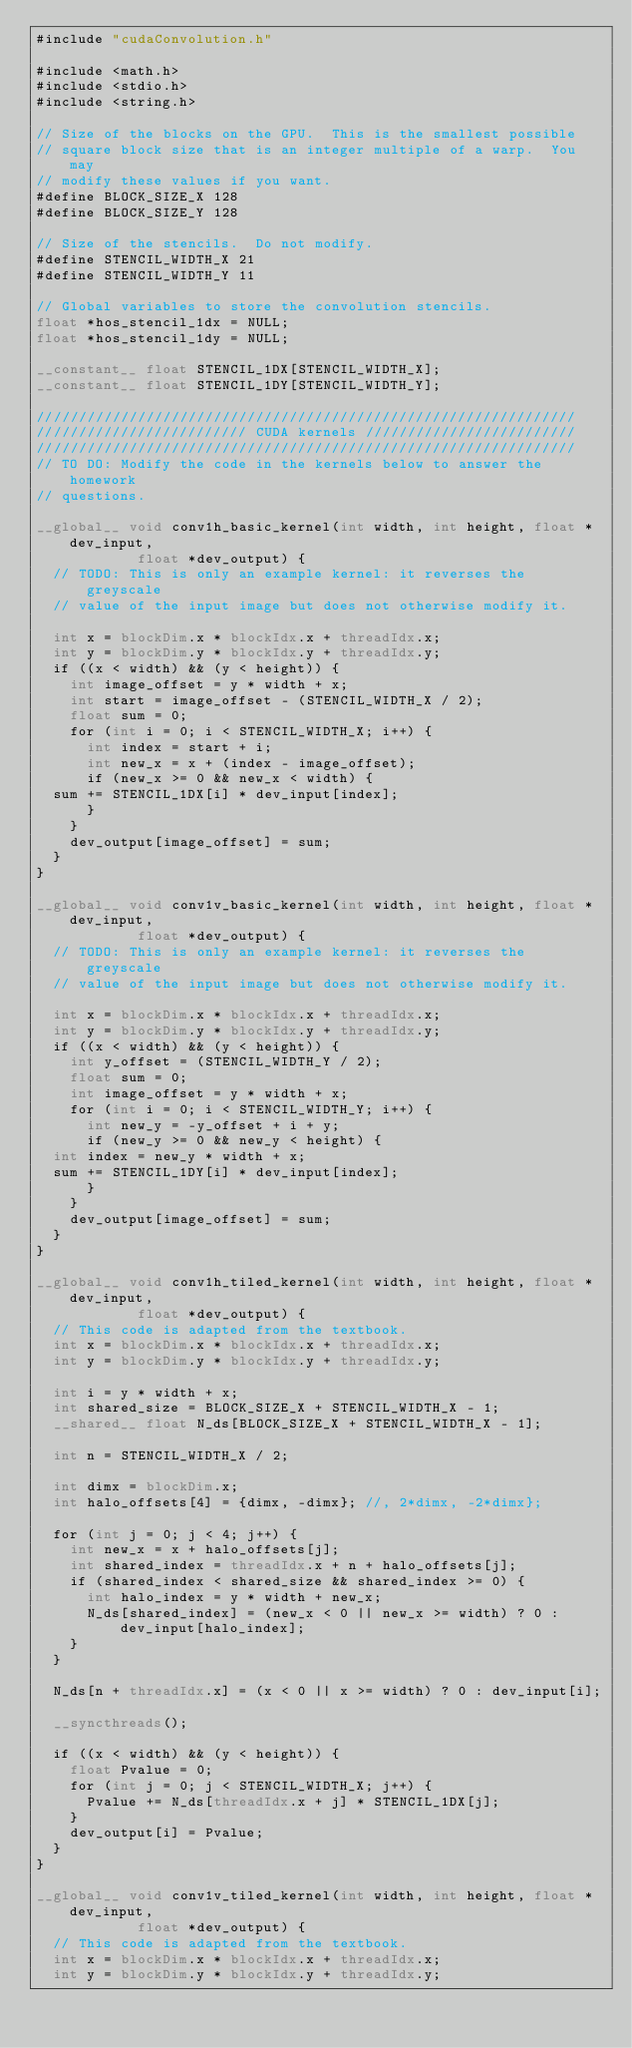<code> <loc_0><loc_0><loc_500><loc_500><_Cuda_>#include "cudaConvolution.h"

#include <math.h>
#include <stdio.h>
#include <string.h>

// Size of the blocks on the GPU.  This is the smallest possible
// square block size that is an integer multiple of a warp.  You may
// modify these values if you want.
#define BLOCK_SIZE_X 128
#define BLOCK_SIZE_Y 128

// Size of the stencils.  Do not modify.
#define STENCIL_WIDTH_X 21
#define STENCIL_WIDTH_Y 11

// Global variables to store the convolution stencils.
float *hos_stencil_1dx = NULL;
float *hos_stencil_1dy = NULL;

__constant__ float STENCIL_1DX[STENCIL_WIDTH_X];
__constant__ float STENCIL_1DY[STENCIL_WIDTH_Y];

////////////////////////////////////////////////////////////////
///////////////////////// CUDA kernels /////////////////////////
////////////////////////////////////////////////////////////////
// TO DO: Modify the code in the kernels below to answer the homework
// questions.

__global__ void conv1h_basic_kernel(int width, int height, float *dev_input,
				    float *dev_output) {
  // TODO: This is only an example kernel: it reverses the greyscale
  // value of the input image but does not otherwise modify it.

  int x = blockDim.x * blockIdx.x + threadIdx.x;
  int y = blockDim.y * blockIdx.y + threadIdx.y;
  if ((x < width) && (y < height)) {
    int image_offset = y * width + x;
    int start = image_offset - (STENCIL_WIDTH_X / 2);
    float sum = 0;
    for (int i = 0; i < STENCIL_WIDTH_X; i++) {
      int index = start + i;
      int new_x = x + (index - image_offset);
      if (new_x >= 0 && new_x < width) {
	sum += STENCIL_1DX[i] * dev_input[index];
      }
    }
    dev_output[image_offset] = sum;
  }
}

__global__ void conv1v_basic_kernel(int width, int height, float *dev_input,
				    float *dev_output) {
  // TODO: This is only an example kernel: it reverses the greyscale
  // value of the input image but does not otherwise modify it.

  int x = blockDim.x * blockIdx.x + threadIdx.x;
  int y = blockDim.y * blockIdx.y + threadIdx.y;
  if ((x < width) && (y < height)) {
    int y_offset = (STENCIL_WIDTH_Y / 2);
    float sum = 0;
    int image_offset = y * width + x;
    for (int i = 0; i < STENCIL_WIDTH_Y; i++) {
      int new_y = -y_offset + i + y;
      if (new_y >= 0 && new_y < height) {
	int index = new_y * width + x;
	sum += STENCIL_1DY[i] * dev_input[index];
      }
    }
    dev_output[image_offset] = sum;
  }
}

__global__ void conv1h_tiled_kernel(int width, int height, float *dev_input,
				    float *dev_output) {
  // This code is adapted from the textbook.
  int x = blockDim.x * blockIdx.x + threadIdx.x;
  int y = blockDim.y * blockIdx.y + threadIdx.y;

  int i = y * width + x;
  int shared_size = BLOCK_SIZE_X + STENCIL_WIDTH_X - 1;
  __shared__ float N_ds[BLOCK_SIZE_X + STENCIL_WIDTH_X - 1];

  int n = STENCIL_WIDTH_X / 2;

  int dimx = blockDim.x;
  int halo_offsets[4] = {dimx, -dimx}; //, 2*dimx, -2*dimx};

  for (int j = 0; j < 4; j++) {
    int new_x = x + halo_offsets[j];
    int shared_index = threadIdx.x + n + halo_offsets[j];
    if (shared_index < shared_size && shared_index >= 0) {
      int halo_index = y * width + new_x;
      N_ds[shared_index] = (new_x < 0 || new_x >= width) ? 0 : dev_input[halo_index];
    }
  }

  N_ds[n + threadIdx.x] = (x < 0 || x >= width) ? 0 : dev_input[i];

  __syncthreads();

  if ((x < width) && (y < height)) {
    float Pvalue = 0;
    for (int j = 0; j < STENCIL_WIDTH_X; j++) {
      Pvalue += N_ds[threadIdx.x + j] * STENCIL_1DX[j];
    }
    dev_output[i] = Pvalue;
  }
}

__global__ void conv1v_tiled_kernel(int width, int height, float *dev_input,
				    float *dev_output) {
  // This code is adapted from the textbook.
  int x = blockDim.x * blockIdx.x + threadIdx.x;
  int y = blockDim.y * blockIdx.y + threadIdx.y;
</code> 